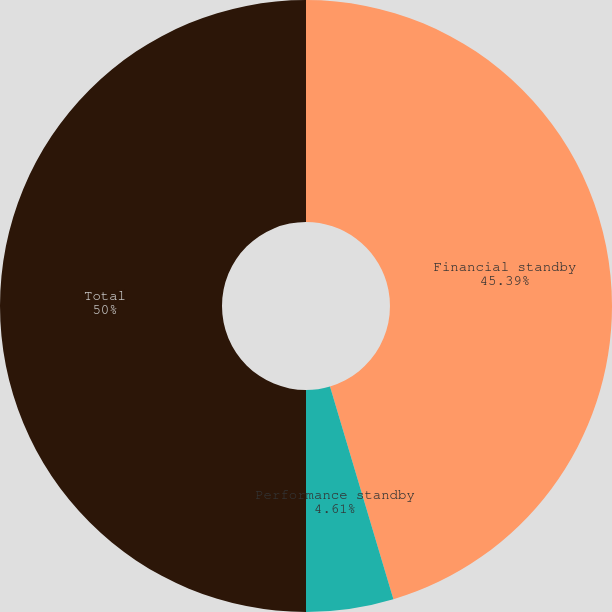<chart> <loc_0><loc_0><loc_500><loc_500><pie_chart><fcel>Financial standby<fcel>Performance standby<fcel>Total<nl><fcel>45.39%<fcel>4.61%<fcel>50.0%<nl></chart> 